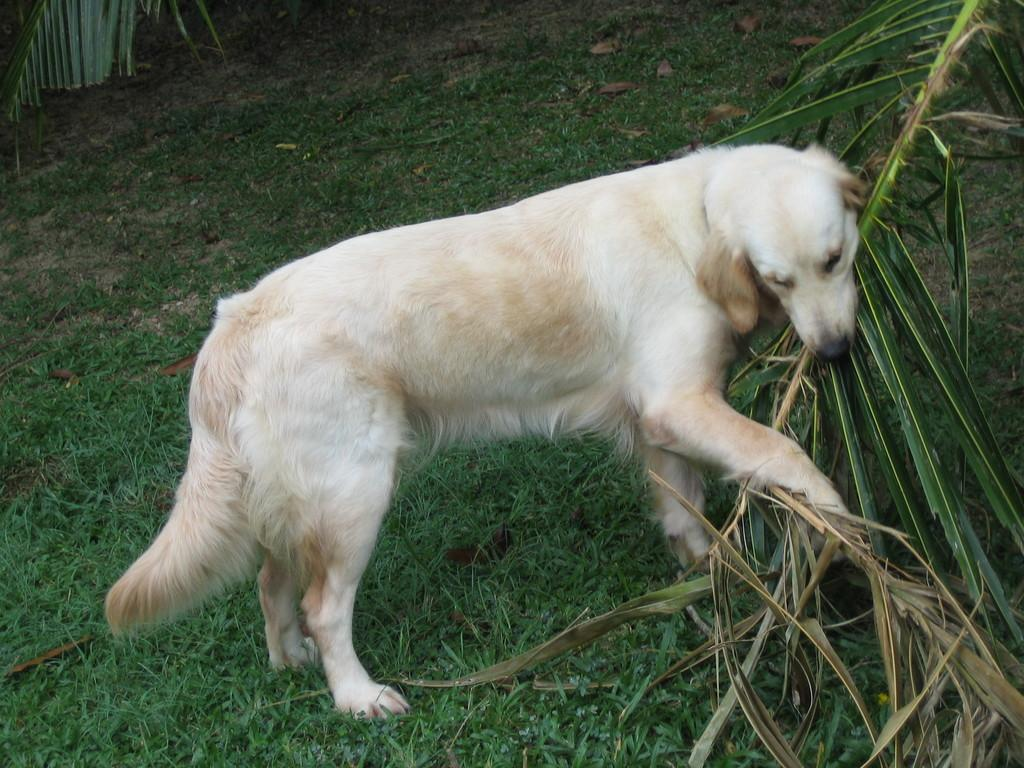What type of animal is in the image? There is a white dog in the image. What is the dog doing in the image? The dog is holding a tree branch in its mouth. What type of terrain is visible at the bottom of the image? There is grass visible at the bottom of the image. What can be seen in the top left part of the image? There is a tree in the left top part of the image. How does the dog express care for the tree branch in the image? The image does not show the dog expressing care for the tree branch; it simply depicts the dog holding the branch in its mouth. 